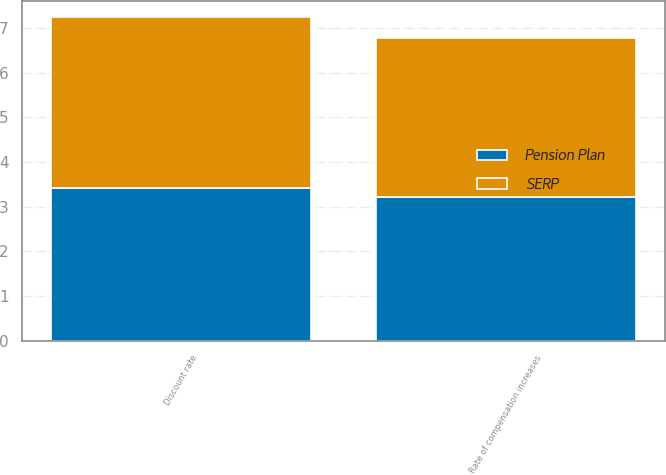Convert chart. <chart><loc_0><loc_0><loc_500><loc_500><stacked_bar_chart><ecel><fcel>Discount rate<fcel>Rate of compensation increases<nl><fcel>SERP<fcel>3.84<fcel>3.57<nl><fcel>Pension Plan<fcel>3.41<fcel>3.21<nl></chart> 